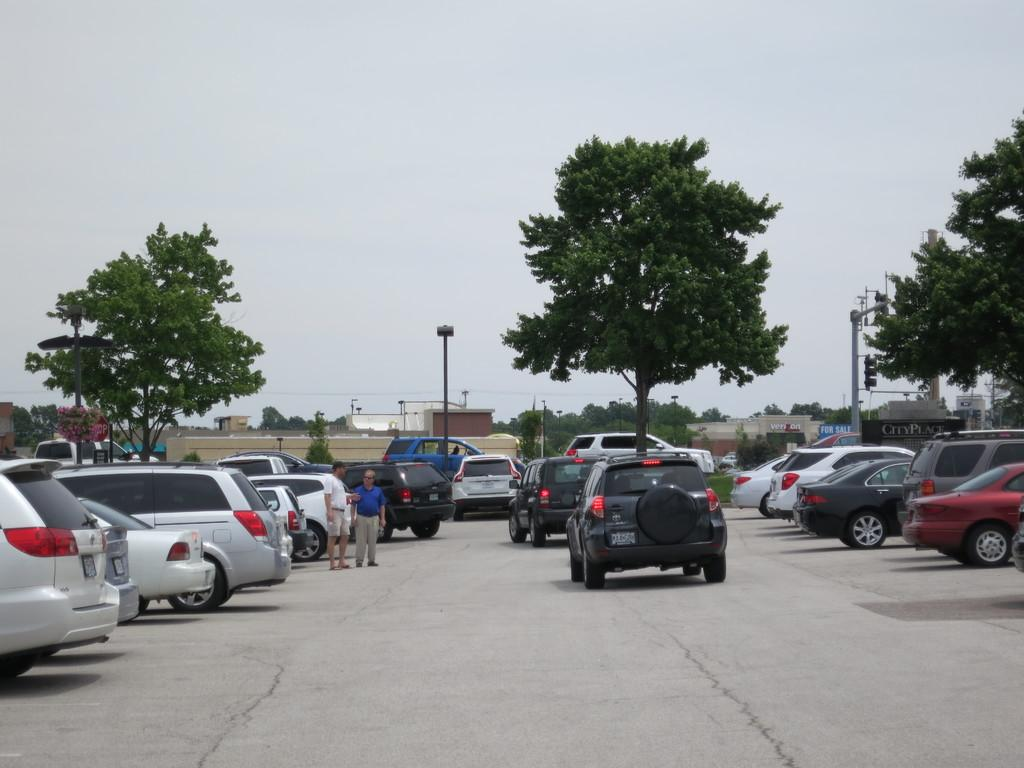What can be seen on the road in the image? There are vehicles parked on the road, and some vehicles are running on the road. What are the people in the image doing? Two persons are standing. What can be seen in the background of the image? There are trees, buildings, poles, and the sky visible in the background. How many chickens are present in the image? There are no chickens present in the image. Is there a garden visible in the image? There is no garden visible in the image. 